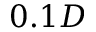Convert formula to latex. <formula><loc_0><loc_0><loc_500><loc_500>0 . 1 D</formula> 